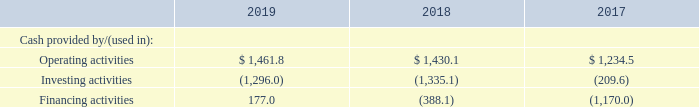FINANCIAL CONDITION, LIQUIDITY AND CAPITAL RESOURCES
All currency amounts are in millions unless specified
Selected cash flows for the years ended December 31, 2019, 2018 and 2017 are as follows:
Operating activities—The growth in cash provided by operating activities in 2019 and in 2018 was primarily due to increased earnings net of non-cash expenses, partially offset by higher cash taxes paid in 2019, most notably cash taxes paid on the gain on sale of the Imaging businesses.
Investing activities—Cash used in investing activities during 2019 was primarily for business acquisitions, most notably iPipeline and Foundry, partially offset by proceeds from the disposal of the Gatan business and the Imaging businesses. Cash used in investing activities during 2018 was primarily for business acquisitions, most notably PowerPlan.
Financing activities—Cash provided by/(used in) financing activities in all periods presented was primarily debt repayments/ borrowings as well as dividends paid to stockholders. Cash provided by financing activities during 2019 was primarily from the issuance of $1.2 billion of senior notes partially offset by $865.0 of revolving debt repayments and to a lesser extent dividend payments. Cash used in financing activities during 2018 was primarily from the pay-down of revolving debt borrowings of $405.0, partially offset by the net issuance of senior notes of $200.0 and dividends paid to shareholders.
Net working capital (current assets, excluding cash, less total current liabilities, excluding debt) was negative $505.4 at December 31, 2019 compared to negative $200.4 at December 31, 2018, due primarily to increased income taxes payable, deferred revenue, and the adoption of ASC 842, partially offset by increased accounts receivable. The increase in income taxes payable is due primarily to the approximately $200.0 of taxes incurred on the gain associated with the divestiture of Gatan. We expect to pay these taxes in the second quarter of 2020. The deferred revenue increase is due to a higher percentage of revenue from software and subscription-based services.
Total debt excluding unamortized debt issuance costs was $5.3 billion at December 31, 2019 (35.9% of total capital) compared to $5.0 billion at December 31, 2018 (39.1% of total capital). Our increased total debt at December 31, 2019 compared to December 31, 2018 was due primarily to the issuance of $500.0 of 2.35% senior unsecured notes and $700.0 of 2.95% senior unsecured notes, partially offset by the pay-down of revolving debt borrowings of $865.0.
On September 23, 2016, we entered into a five-year unsecured credit facility, as amended as of December 2, 2016 (the “2016 Facility”) with JPMorgan Chase Bank, N.A., as administrative agent, and a syndicate of lenders, which replaced our previous unse- cured credit facility, dated as of July 27, 2012, as amended as of October 28, 2015 (the “2012 Facility”). The 2016 Facility comprises a five year $2.5 billion revolving credit facility, which includes availability of up to $150.0 for letters of credit. We may also, subject to compliance with specified conditions, request term loans or additional revolving credit commitments in an aggregate amount not to exceed $500.0.
The 2016 Facility contains various affirmative and negative covenants which, among other things, limit our ability to incur new debt, enter into certain mergers and acquisitions, sell assets and grant liens, make restricted payments (including the payment of dividends on our common stock) and capital expenditures, or change our line of business. We also are subject to financial cove- nants which require us to limit our consolidated total leverage ratio and to maintain a consolidated interest coverage ratio. The most restrictive covenant is the consolidated total leverage ratio which is limited to 3.5 to 1.
The 2016 Facility provides that the consolidated total leverage ratio may be increased, no more than twice during the term of the 2016 Facility, to 4.00 to 1 for a consecutive four quarter fiscal period per increase (or, for any portion of such four quarter fiscal period in which the maximum would be 4.25 to 1). In conjunction with the Deltek acquisition in December of 2016, we increased the maximum consolidated total leverage ratio covenant to 4.25 to 1 through June 30, 2017 and 4.00 to 1 through December 31, 2017.
At December 31, 2019, we had $5.3 billion of senior unsecured notes and $0.0 of outstanding revolver borrowings. In addition, we had $7.7 of other debt in the form of finance leases and several smaller facilities that allow for borrowings or the issuance of letters of credit in foreign locations to support our non-U.S. businesses. We had $74.0 of outstanding letters of credit at December 31, 2019, of which $35.8 was covered by our lending group, thereby reducing our revolving credit capacity commensurately.
We may redeem some or all of our senior secured notes at any time or from time to time, at 100% of their principal amount, plus a make-whole premium based on a spread to U.S. Treasury securities.
We were in compliance with all debt covenants related to our credit facility throughout the years ended December 31, 2019 and 2018.
See Note 8 of the Notes to Consolidated Financial Statements included in this Annual Report for additional information regarding our credit facility and senior notes.
Cash and cash equivalents at our foreign subsidiaries at December 31, 2019 totaled $291.8 as compared to $339.0 at December 31, 2018, a decrease of 13.9%. The decrease was due primarily to the repatriation of $290.6 during the year and cash used in the acquisition of Foundry, partially offset by cash generated from foreign operations. We intend to repatriate substantially all historical and future earnings subject to the deemed repatriation tax.
Capital expenditures of $52.7, $49.1 and $48.8 were incurred during 2019, 2018 and 2017, respectively. Capitalized software expenditures of $10.2, $9.5 and $10.8 were incurred during 2019, 2018 and 2017, respectively. Capital expenditures and capitalized software expenditures were relatively consistent in 2019 as compared to 2018 and 2017. In the future, we expect the aggregate of capital expenditures and capitalized software expenditures as a percentage of annual net revenues to be between 1.0% and 1.5%.
What was the cause of growth in cash provided by operating activities in 2018 and 2019? Increased earnings net of non-cash expenses, partially offset by higher cash taxes paid in 2019, most notably cash taxes paid on the gain on sale of the imaging businesses. How was the cash used in investing activities during 2018? Primarily for business acquisitions, most notably powerplan. How much was the cash provided by financing activities in 2019?
Answer scale should be: million. 177.0. Which year did operating activities provide the most cash? 1,461.8>1,430.1>1,234.5
Answer: 2019. What is the change in cash provided by operating activities between 2018 and 2019?
Answer scale should be: million. 1,461.8-1,430.1
Answer: 31.7. What is the total amount of cash in 2019?
Answer scale should be: million. 1,461.8+(-1,296.0)+177.0 
Answer: 342.8. 